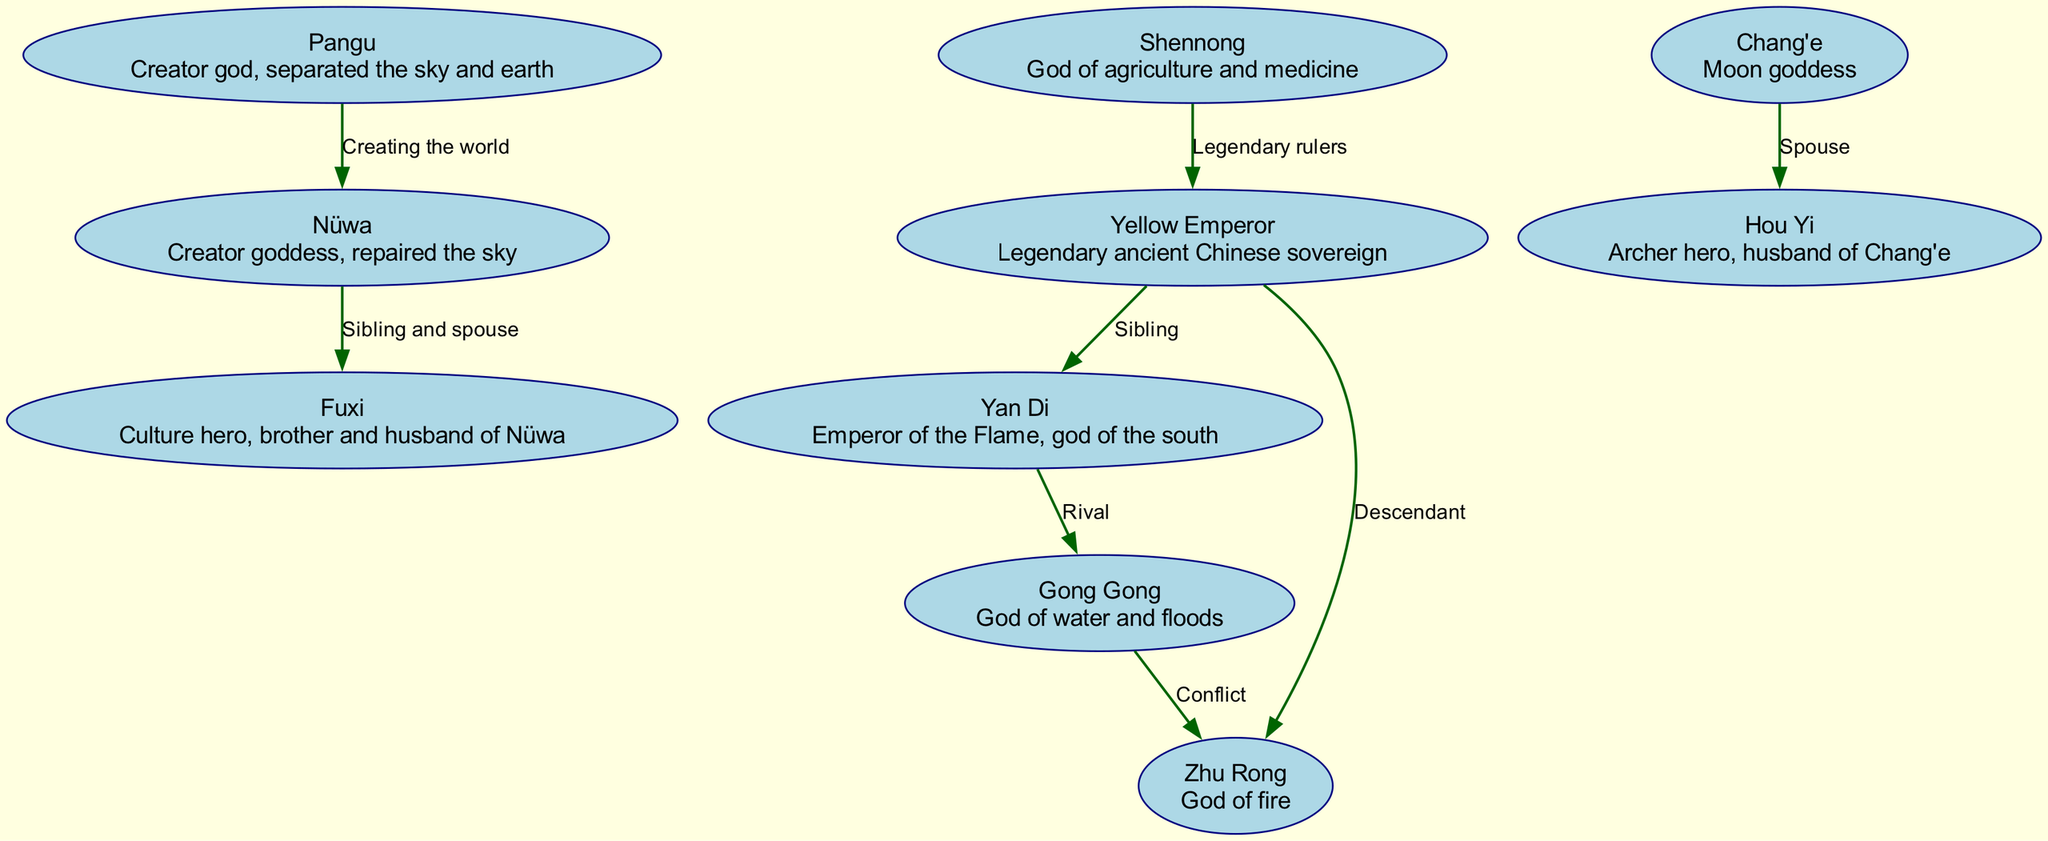What is the role of Pangu in the diagram? Pangu is labeled as the 'Creator god' who 'separated the sky and earth,' indicating his primary role in the family tree as the initiator of creation.
Answer: Creator god Who is the sibling and spouse of Nüwa? The diagram explicitly states that Fuxi is both a sibling and spouse of Nüwa, which is noted in the relationship between Nüwa and Fuxi.
Answer: Fuxi How many nodes are present in the family tree? By counting the entries in the nodes section of the data, there are 10 unique gods and spirits depicted in the family tree.
Answer: 10 What relationship exists between Yan Di and Gong Gong? The diagram describes their connection as 'Rival,' which highlights the nature of their relationship as adversarial.
Answer: Rival Identify a descendant of the Yellow Emperor. The diagram shows that Zhu Rong is connected as a 'Descendant' of the Yellow Emperor, illustrating the lineage between them.
Answer: Zhu Rong Which pair of gods represents a conflict in the diagram? The edges indicate a 'Conflict' relationship between Gong Gong and Zhu Rong, establishing their contentious interaction.
Answer: Gong Gong and Zhu Rong Who is Chang'e's spouse according to the family tree? The diagram directly states that Hou Yi holds the position of 'Spouse' to Chang'e, defining their familial tie.
Answer: Hou Yi What is the relationship between Shennong and the Yellow Emperor? The connection is categorized under 'Legendary rulers,' suggesting they share a common status in the mythological hierarchy.
Answer: Legendary rulers Which god is depicted as the god of agriculture? According to the description in the nodes, Shennong is specifically identified as the 'God of agriculture and medicine.'
Answer: Shennong How are the Yellow Emperor and Yan Di related? The diagram indicates a direct familial relationship, stating they are 'Siblings,' which outlines their connection in the ancestry.
Answer: Sibling 